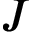<formula> <loc_0><loc_0><loc_500><loc_500>J</formula> 